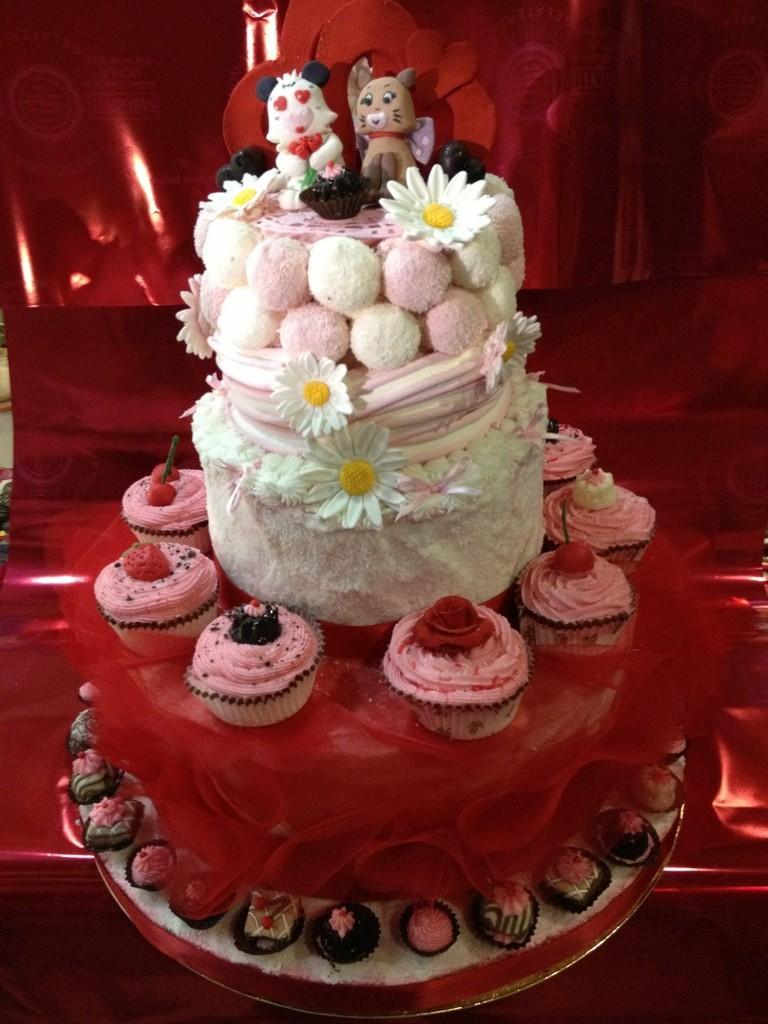In one or two sentences, can you explain what this image depicts? In this image we can able to see a cake, there are some cupcakes around it and background is red in color. 